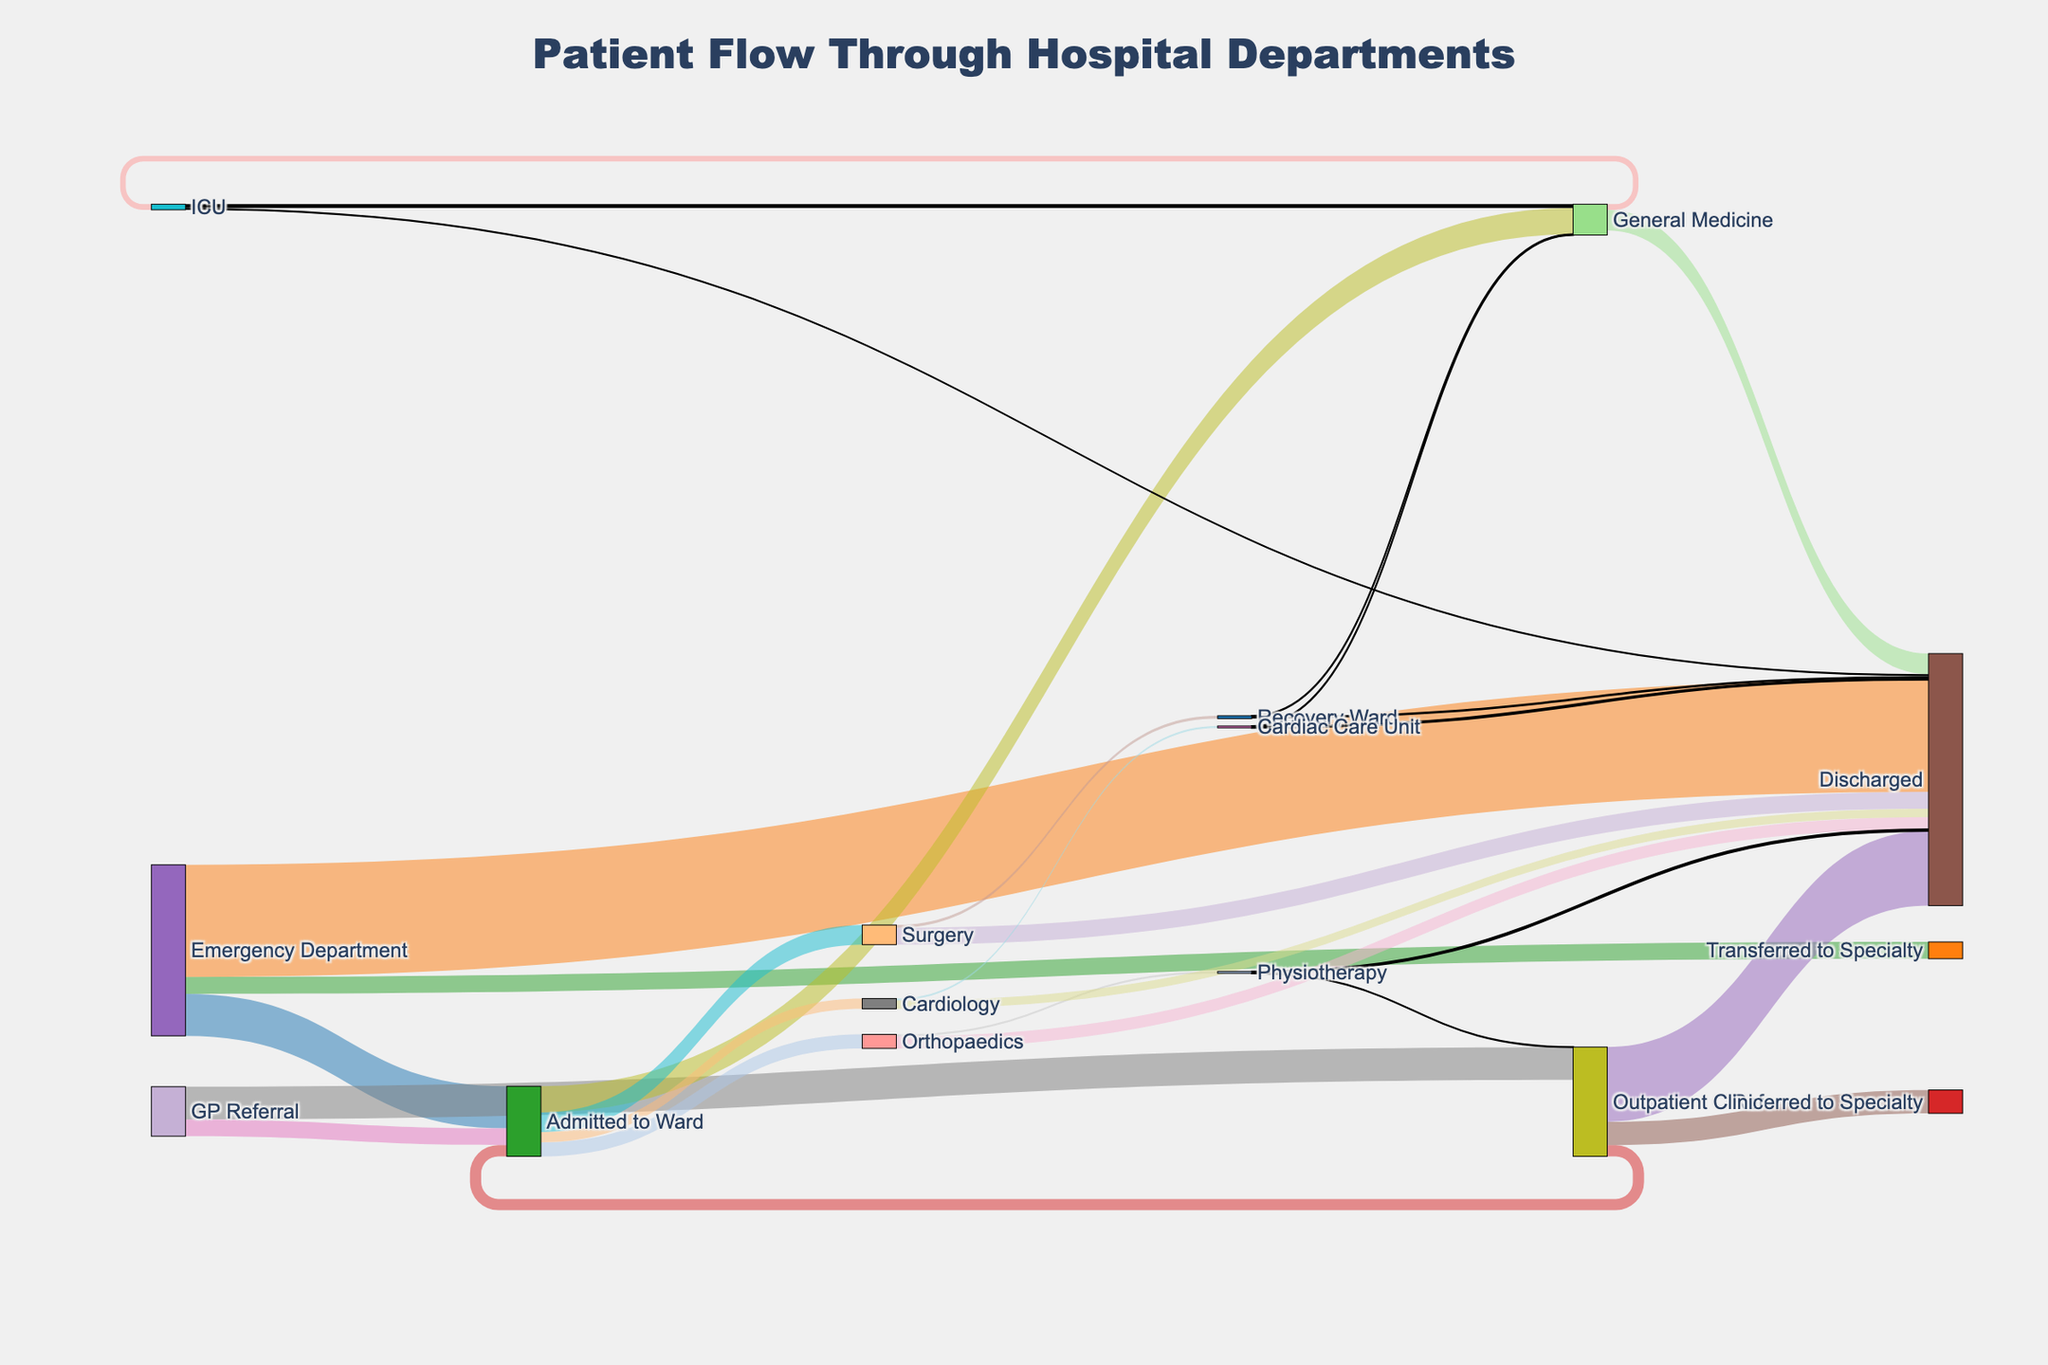How many patients are discharged from the Emergency Department during a typical week? The Sankey diagram displays that the flow from the Emergency Department to Discharged has a value of 1200 patients.
Answer: 1200 Which department receives the most patient admissions from the Emergency Department? According to the diagram, the flow from the Emergency Department to Admitted to Ward has a value of 450, and to Transferred to Specialty has a value of 180. The highest is Admitted to Ward with 450 patients.
Answer: Admitted to Ward What is the total number of patients flowing through the Outpatient Clinic? The number of patients discharged (800), admitted to ward (120), and referred to specialty (250) are the flows through the Outpatient Clinic. Summing these values gives 800 + 120 + 250 = 1170.
Answer: 1170 Which specialty receives the least referrals from the Admitted to Ward category? Looking at the diagram, Cardiology receives 110 patients, Orthopaedics 150, Surgery 210, and General Medicine 280. Cardiology receives the least with 110 patients.
Answer: Cardiology How many patients coming from GP Referral are referred to the Outpatient Clinic? The diagram highlights that the flow from GP Referral to Outpatient Clinic is represented by a value of 350 patients.
Answer: 350 What is the total number of patients discharged either directly from ICU or via Recovery Ward? Patients discharged directly from ICU are 20, and from Recovery Ward are 25. Therefore, the total is 20 + 25 = 45 patients.
Answer: 45 Which has more patients transferred to other specialties: the Emergency Department or the Outpatient Clinic? The flow from Emergency Department to Transferred to Specialty is 180 patients, while the Outpatient Clinic to Referred to Specialty is 250 patients. Thus, the Outpatient Clinic has more patients transferred to specialties.
Answer: Outpatient Clinic Where do the majority of physiotherapy patients go after treatment is done? The Sankey diagram shows that 18 patients go to Discharged and 2 return to the Outpatient Clinic. The majority of patients go to Discharged.
Answer: Discharged How many patients are flowing through the General Medicine section either directly or via later transfers? The flows involving General Medicine are incoming from Admitted to Ward (280) and further transferred to ICU (60), as well as incoming from ICU (40) and transfer from Recovery Ward (5). Outgoing flows include to Discharged (220). Therefore, sum of these numbers is 280 + 60 + 40 + 5 + 220 = 605.
Answer: 605 What percentage of the total patients entering the hospital through the Emergency Department are eventually discharged from either Surgery or Orthopaedics? The total from Emergency Department is 450 + 1200 + 180 = 1830. From these, Surgery discharges 180 and Orthopaedics discharges 130, so their sum is 310. The percentage is (310 / 1830) * 100 ≈ 16.94%.
Answer: 16.94% 